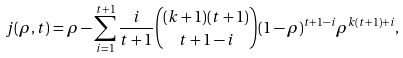<formula> <loc_0><loc_0><loc_500><loc_500>j ( \rho , t ) = \rho - \sum _ { i = 1 } ^ { t + 1 } \frac { i } { t + 1 } { { ( k + 1 ) ( t + 1 ) } \choose { t + 1 - i } } ( 1 - \rho ) ^ { t + 1 - i } \rho ^ { k ( t + 1 ) + i } ,</formula> 